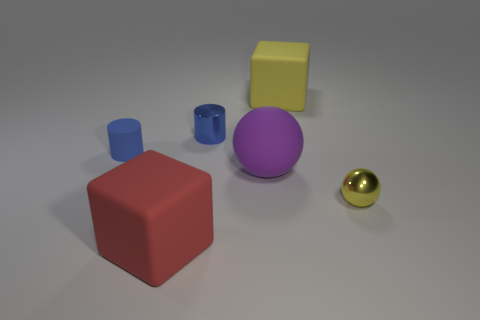Add 3 blocks. How many objects exist? 9 Subtract all yellow blocks. How many blocks are left? 1 Subtract 0 green cylinders. How many objects are left? 6 Subtract all cylinders. How many objects are left? 4 Subtract 2 cubes. How many cubes are left? 0 Subtract all green cylinders. Subtract all green spheres. How many cylinders are left? 2 Subtract all blue balls. How many yellow blocks are left? 1 Subtract all small blue cylinders. Subtract all red rubber cubes. How many objects are left? 3 Add 5 blue things. How many blue things are left? 7 Add 3 tiny blue cylinders. How many tiny blue cylinders exist? 5 